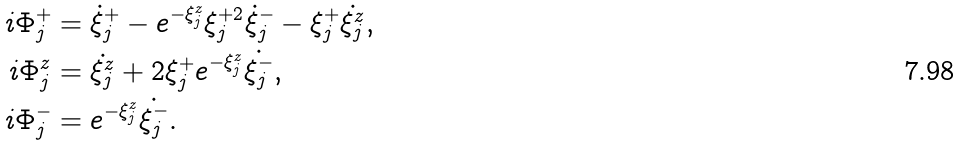<formula> <loc_0><loc_0><loc_500><loc_500>i \Phi _ { j } ^ { + } & = \dot { \xi } _ { j } ^ { + } - e ^ { - \xi _ { j } ^ { z } } \xi _ { j } ^ { + 2 } \dot { \xi } _ { j } ^ { - } - \xi _ { j } ^ { + } \dot { \xi _ { j } ^ { z } } , \\ i \Phi _ { j } ^ { z } & = \dot { \xi _ { j } ^ { z } } + 2 \xi _ { j } ^ { + } e ^ { - \xi _ { j } ^ { z } } \dot { \xi _ { j } ^ { - } } , \\ i \Phi _ { j } ^ { - } & = e ^ { - \xi _ { j } ^ { z } } \dot { \xi _ { j } ^ { - } } .</formula> 